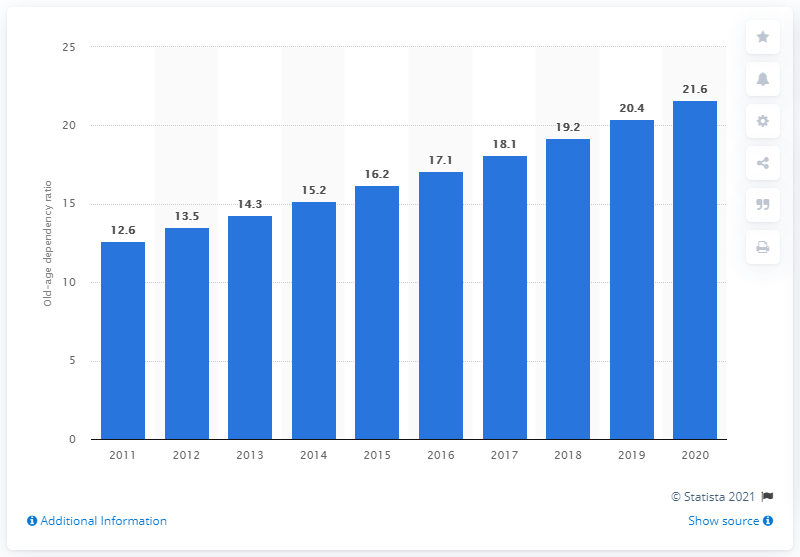List a handful of essential elements in this visual. In 2020, the old-age dependency ratio in Singapore was 21.6, indicating that there were 21.6 people aged 65 years or older for every 100 people of working age. In 2011, the old-age dependency ratio in Singapore was 12.6. The highest old-age dependency ratio in Singapore between the years 2011 and 2020 was 24.3%, while the lowest was 15.5%. In 2019, the old-age dependency ratio in Singapore was 20.4. This indicates that there were 20.4 people aged 65 and above for every 100 people aged 20 to 64. 